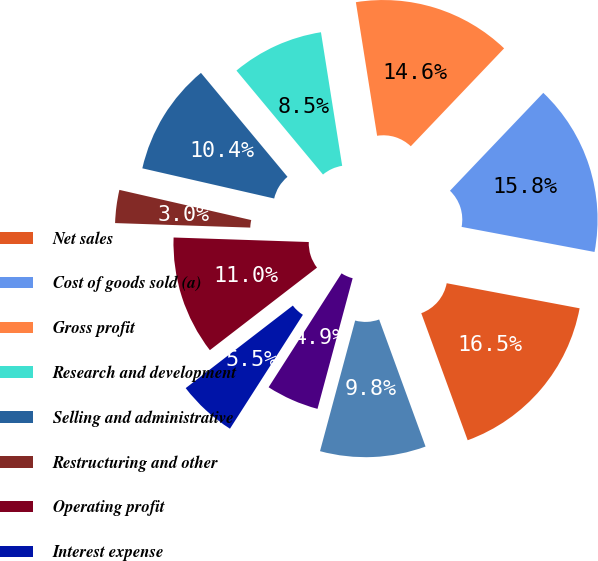Convert chart. <chart><loc_0><loc_0><loc_500><loc_500><pie_chart><fcel>Net sales<fcel>Cost of goods sold (a)<fcel>Gross profit<fcel>Research and development<fcel>Selling and administrative<fcel>Restructuring and other<fcel>Operating profit<fcel>Interest expense<fcel>Other (income) expense net (d)<fcel>Income before taxes<nl><fcel>16.46%<fcel>15.85%<fcel>14.63%<fcel>8.54%<fcel>10.37%<fcel>3.05%<fcel>10.98%<fcel>5.49%<fcel>4.88%<fcel>9.76%<nl></chart> 